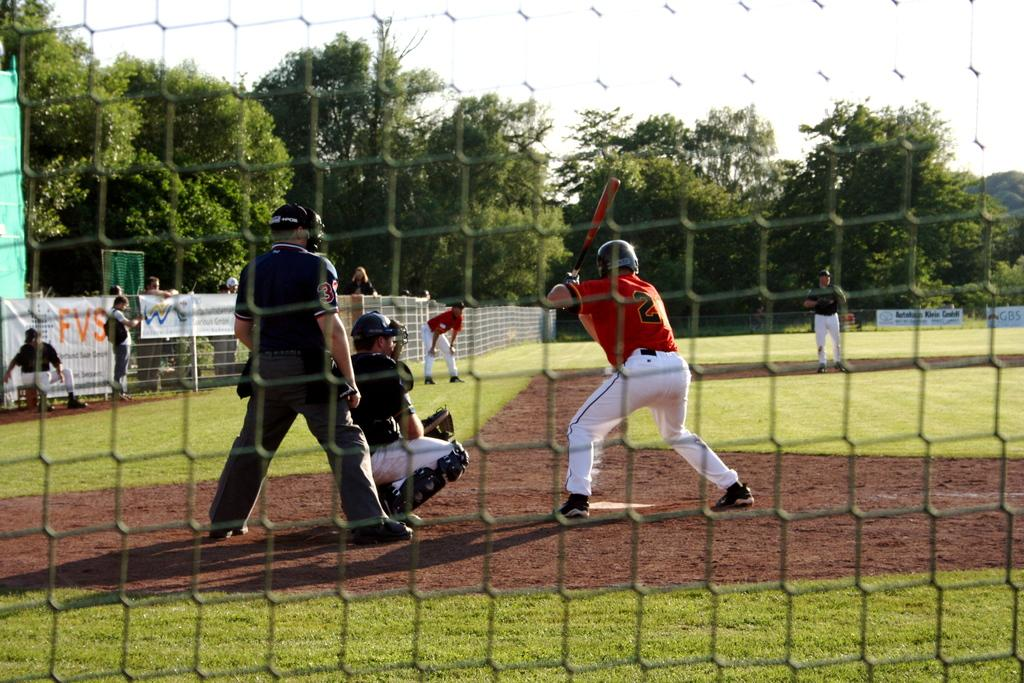Provide a one-sentence caption for the provided image. A baseball player, whose jersey number is 21, is at-bat. 